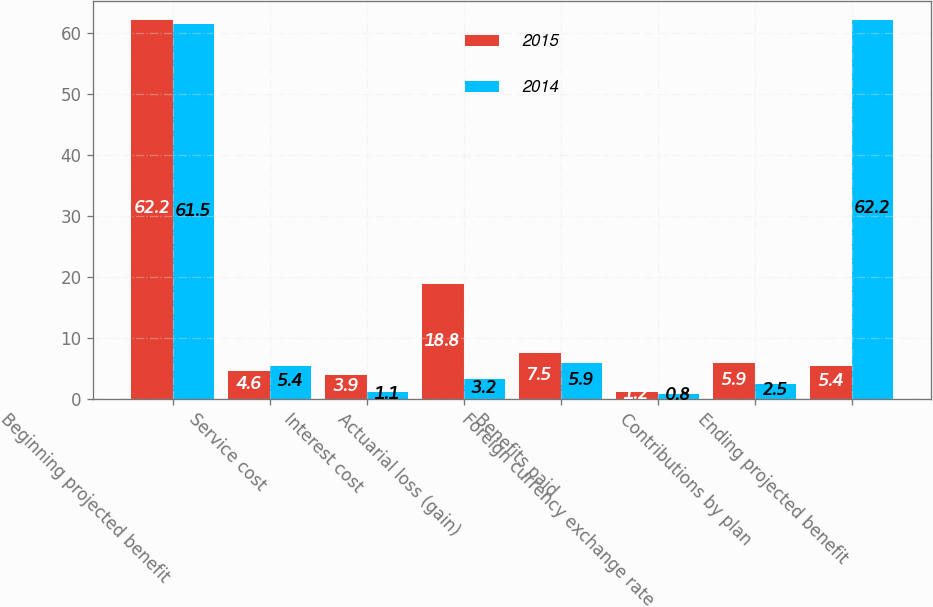<chart> <loc_0><loc_0><loc_500><loc_500><stacked_bar_chart><ecel><fcel>Beginning projected benefit<fcel>Service cost<fcel>Interest cost<fcel>Actuarial loss (gain)<fcel>Benefits paid<fcel>Foreign currency exchange rate<fcel>Contributions by plan<fcel>Ending projected benefit<nl><fcel>2015<fcel>62.2<fcel>4.6<fcel>3.9<fcel>18.8<fcel>7.5<fcel>1.2<fcel>5.9<fcel>5.4<nl><fcel>2014<fcel>61.5<fcel>5.4<fcel>1.1<fcel>3.2<fcel>5.9<fcel>0.8<fcel>2.5<fcel>62.2<nl></chart> 